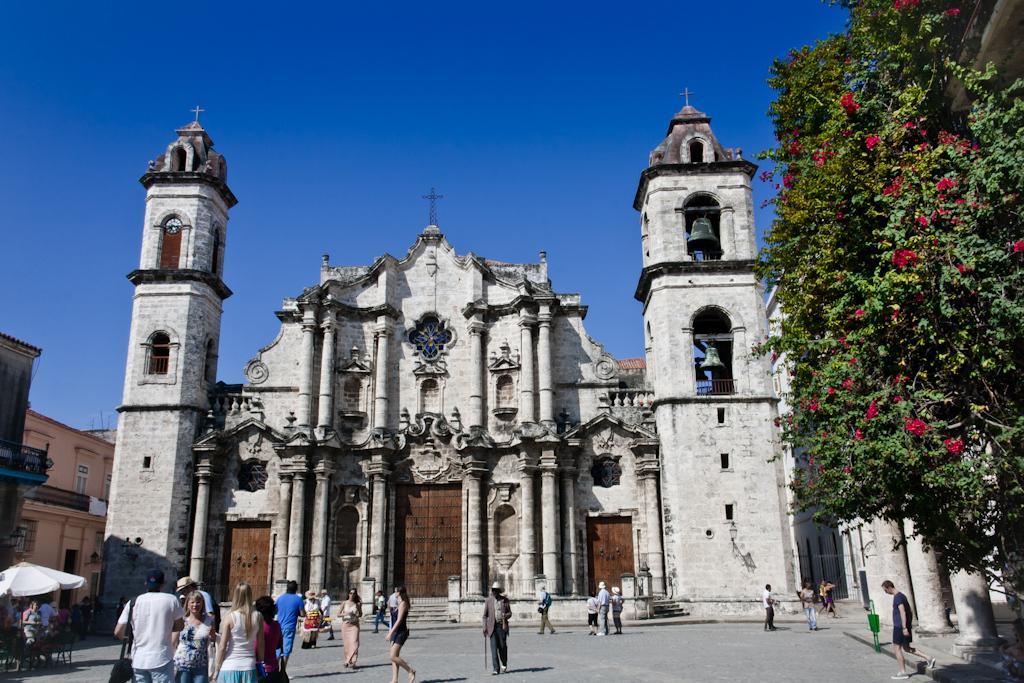Describe this image in one or two sentences. In the foreground of this image, there is a church. On bottom, there are persons on the ground. On right, there is a tree with flowers. On left, there are buildings, an umbrella and the sky. 